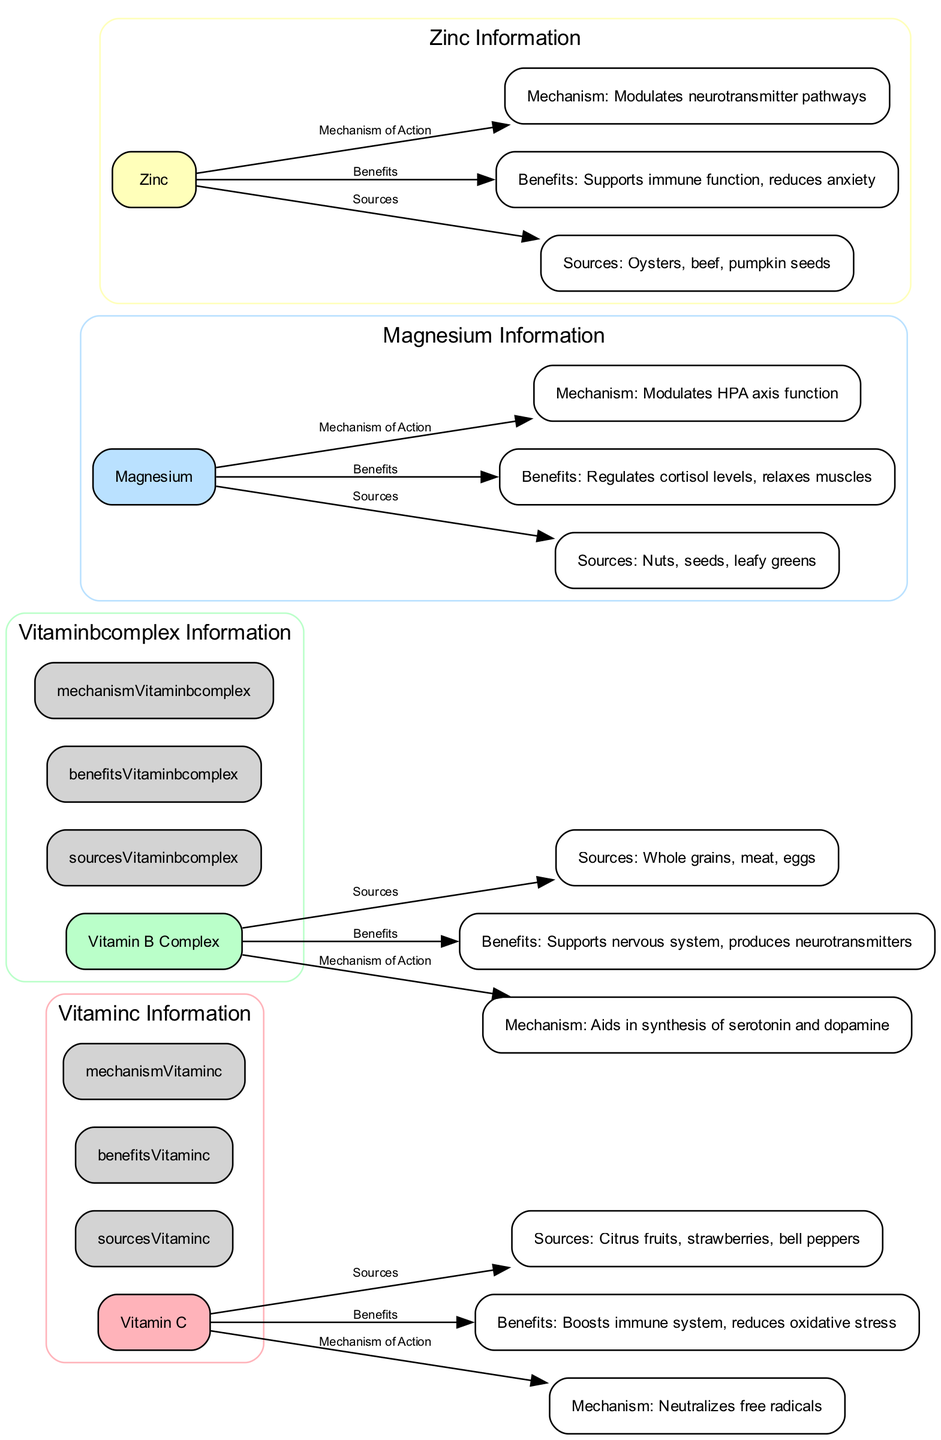What are the sources of Vitamin C? The diagram lists “Sources: Citrus fruits, strawberries, bell peppers” connected to the Vitamin C node, indicating these foods provide Vitamin C.
Answer: Citrus fruits, strawberries, bell peppers How many vitamins and minerals are detailed in the diagram? By counting the nodes corresponding to vitamins and minerals (Vitamin C, Vitamin B Complex, Magnesium, Zinc), there are a total of four.
Answer: 4 What benefit does Magnesium provide? The diagram shows “Benefits: Regulates cortisol levels, relaxes muscles” as linked to the Magnesium node, indicating these are the benefits of Magnesium.
Answer: Regulates cortisol levels, relaxes muscles Which vitamin helps in the synthesis of serotonin and dopamine? The diagram specifies “Mechanism: Aids in synthesis of serotonin and dopamine” linked to the Vitamin B Complex node, indicating it plays this role.
Answer: Vitamin B Complex What is the mechanism of action for Zinc? The diagram states “Mechanism: Modulates neurotransmitter pathways” connected to the Zinc node, indicating how Zinc functions in this context.
Answer: Modulates neurotransmitter pathways Which nutrient has the benefit of reducing anxiety? The diagram connects “Benefits: Supports immune function, reduces anxiety” to the Zinc node, indicating that Zinc is associated with this benefit.
Answer: Zinc What color represents Magnesium in the diagram? The diagram assigns a specific color to Magnesium, which is light blue as represented in the color palette for the nodes.
Answer: Light blue What are the sources of Vitamin B Complex? The diagram indicates “Sources: Whole grains, meat, eggs” linked to the Vitamin B Complex node, identifying these as its sources.
Answer: Whole grains, meat, eggs How does Vitamin C help the body? The diagram states “Benefits: Boosts immune system, reduces oxidative stress” which explains how Vitamin C provides support to the body.
Answer: Boosts immune system, reduces oxidative stress 